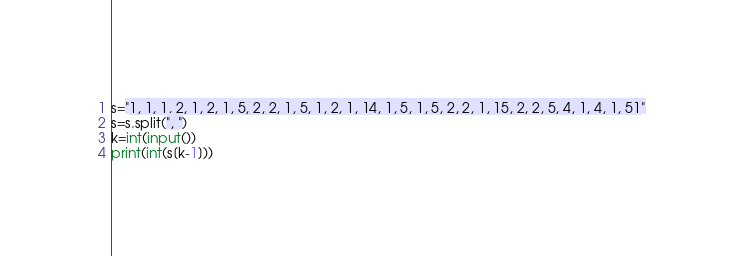<code> <loc_0><loc_0><loc_500><loc_500><_Python_>s="1, 1, 1, 2, 1, 2, 1, 5, 2, 2, 1, 5, 1, 2, 1, 14, 1, 5, 1, 5, 2, 2, 1, 15, 2, 2, 5, 4, 1, 4, 1, 51"
s=s.split(", ")
k=int(input())
print(int(s[k-1]))</code> 